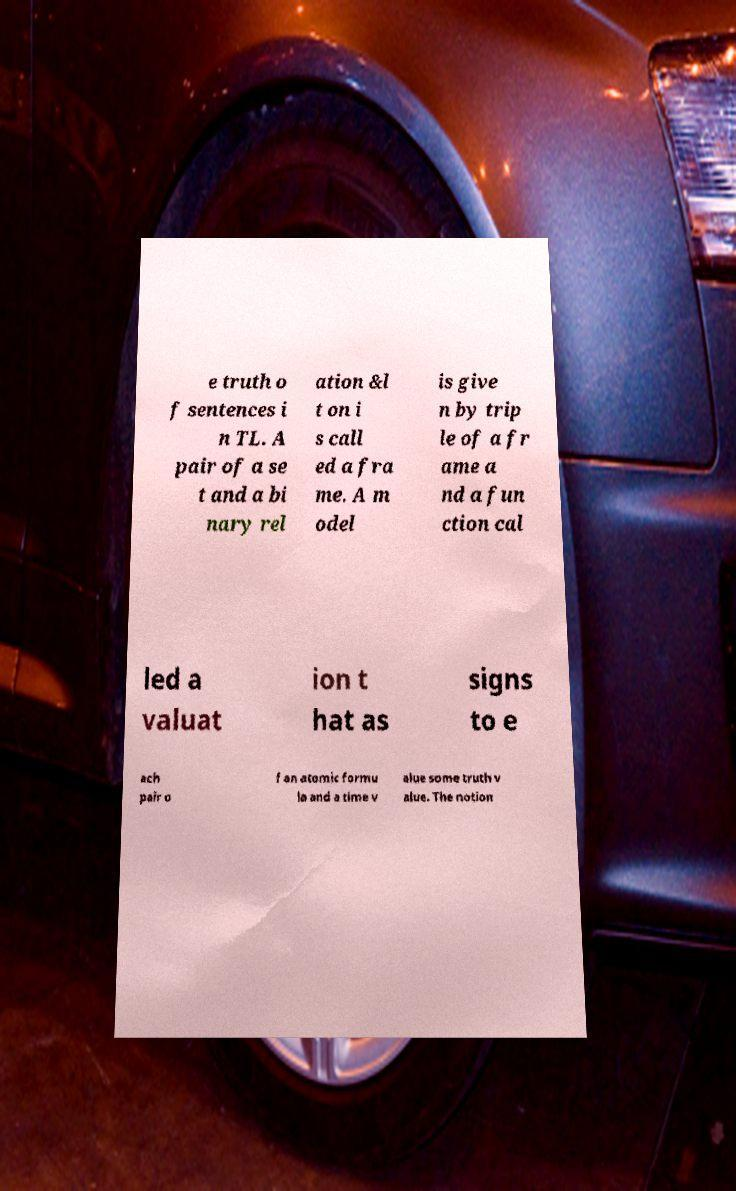Could you extract and type out the text from this image? e truth o f sentences i n TL. A pair of a se t and a bi nary rel ation &l t on i s call ed a fra me. A m odel is give n by trip le of a fr ame a nd a fun ction cal led a valuat ion t hat as signs to e ach pair o f an atomic formu la and a time v alue some truth v alue. The notion 